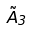Convert formula to latex. <formula><loc_0><loc_0><loc_500><loc_500>\tilde { A } _ { 3 }</formula> 